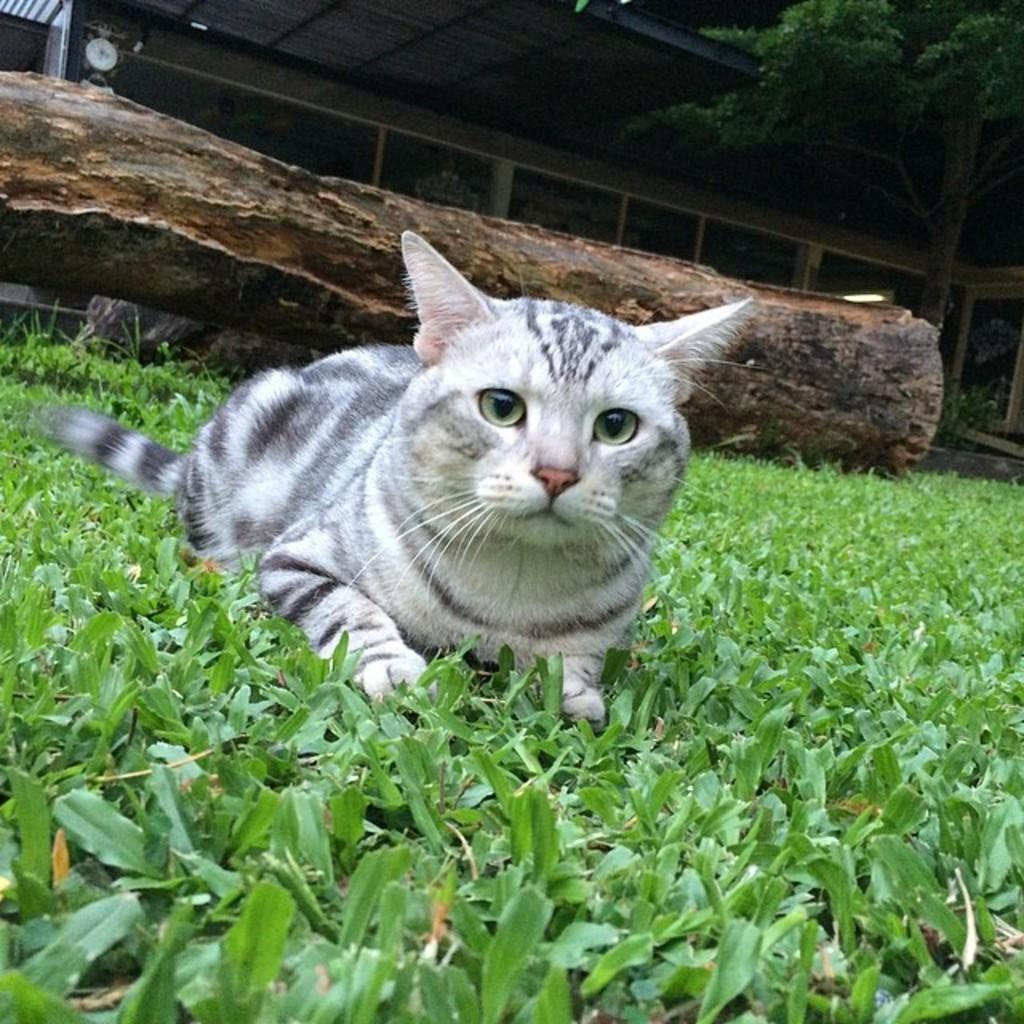In one or two sentences, can you explain what this image depicts? In this picture there is a cat in the center of the image on the grassland, there is a log behind it, there are windows, trees, and a roof at the top side of the image. 